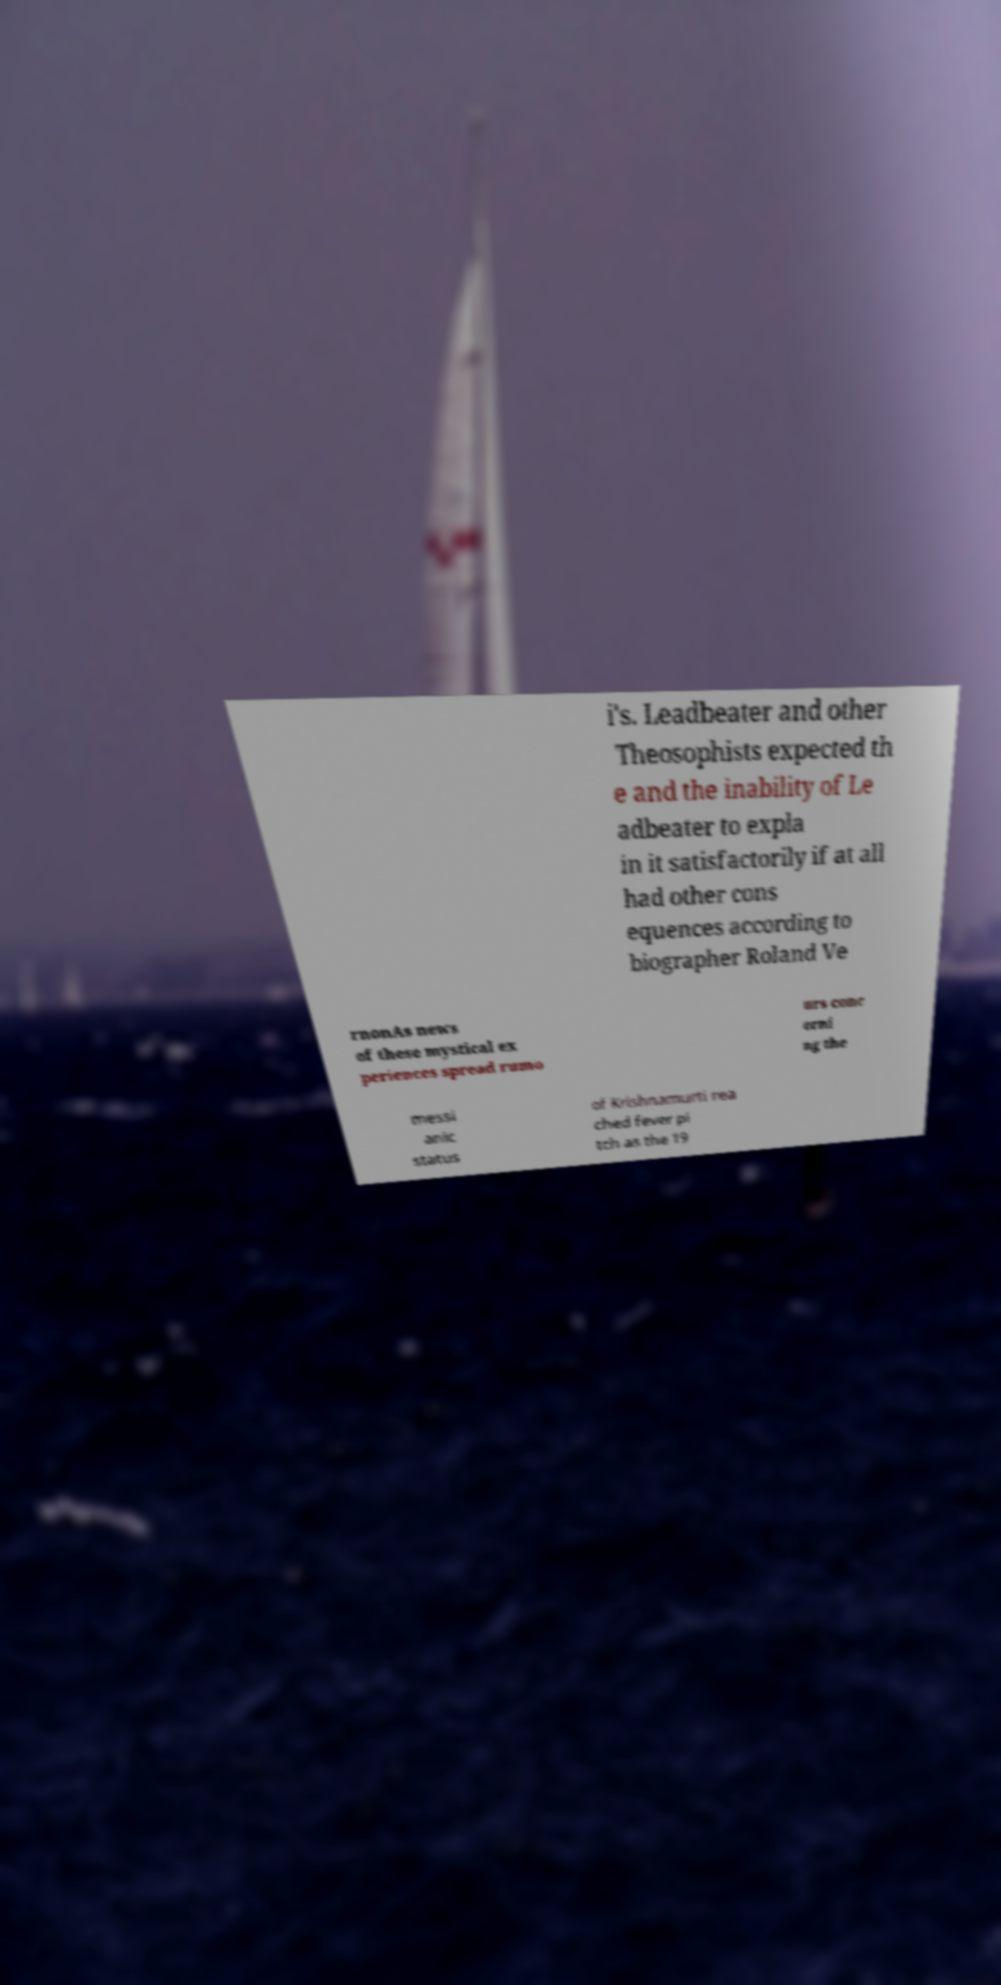Please identify and transcribe the text found in this image. i's. Leadbeater and other Theosophists expected th e and the inability of Le adbeater to expla in it satisfactorily if at all had other cons equences according to biographer Roland Ve rnonAs news of these mystical ex periences spread rumo urs conc erni ng the messi anic status of Krishnamurti rea ched fever pi tch as the 19 